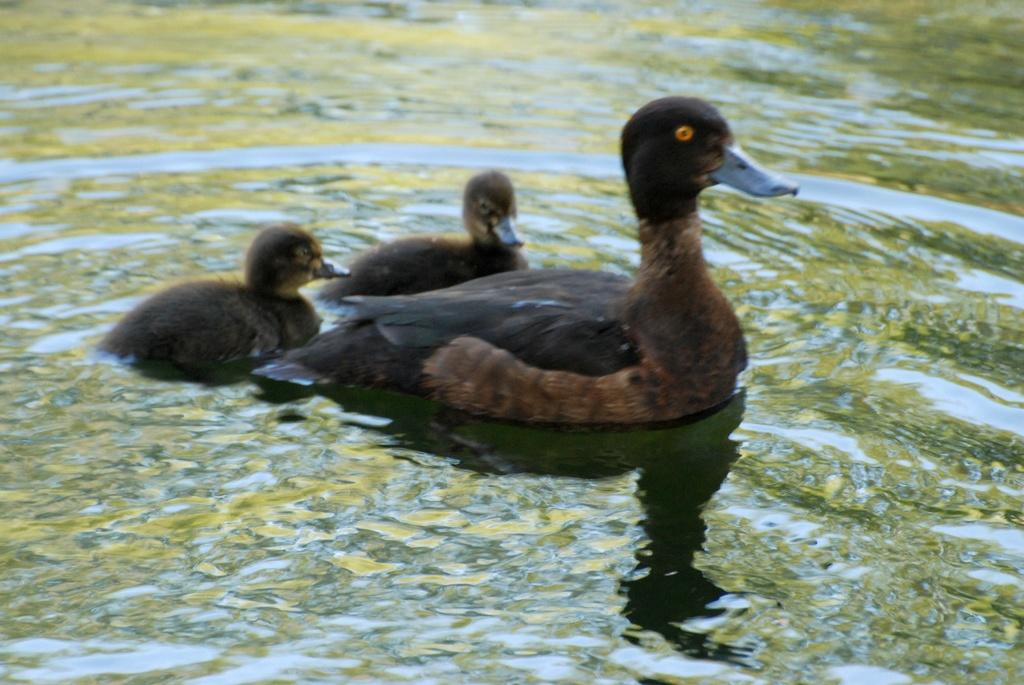What type of animals can be seen in the image? There are ducks in the image. Where are the ducks located? The ducks are on the water. What type of control system is being used by the ducks in the image? There is no control system present in the image; the ducks are simply floating on the water. 